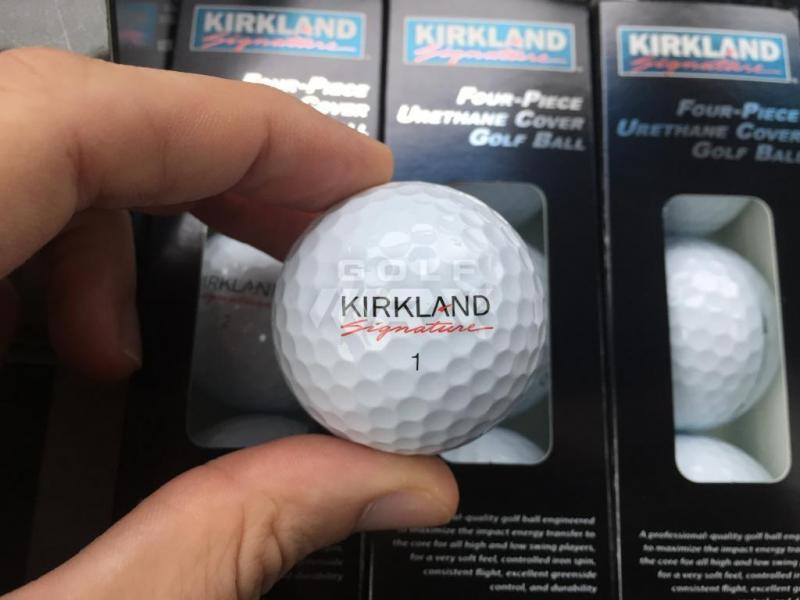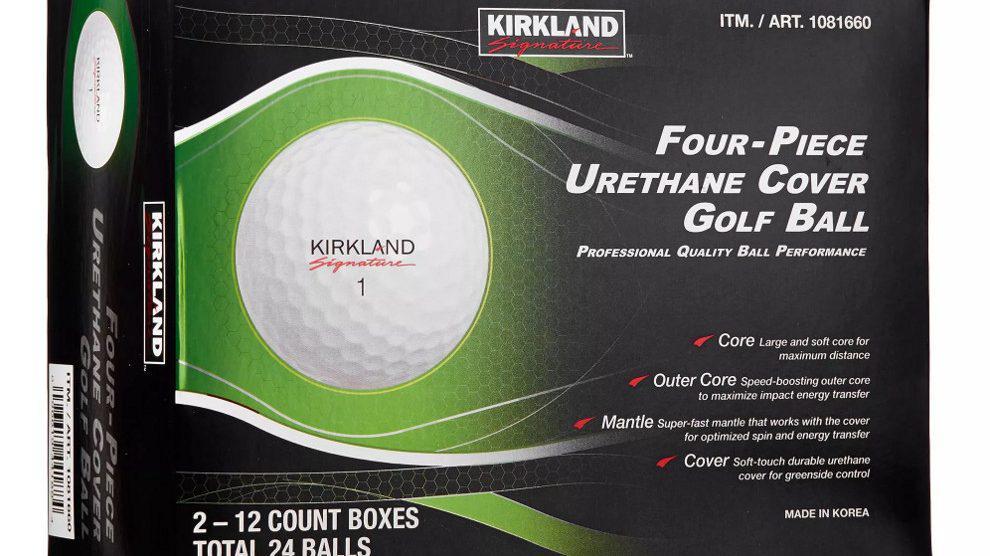The first image is the image on the left, the second image is the image on the right. Analyze the images presented: Is the assertion "At least one image includes a golf ball that is not in a package in front of golf balls in a package." valid? Answer yes or no. Yes. The first image is the image on the left, the second image is the image on the right. Considering the images on both sides, is "Two golf balls are not in a box." valid? Answer yes or no. No. 